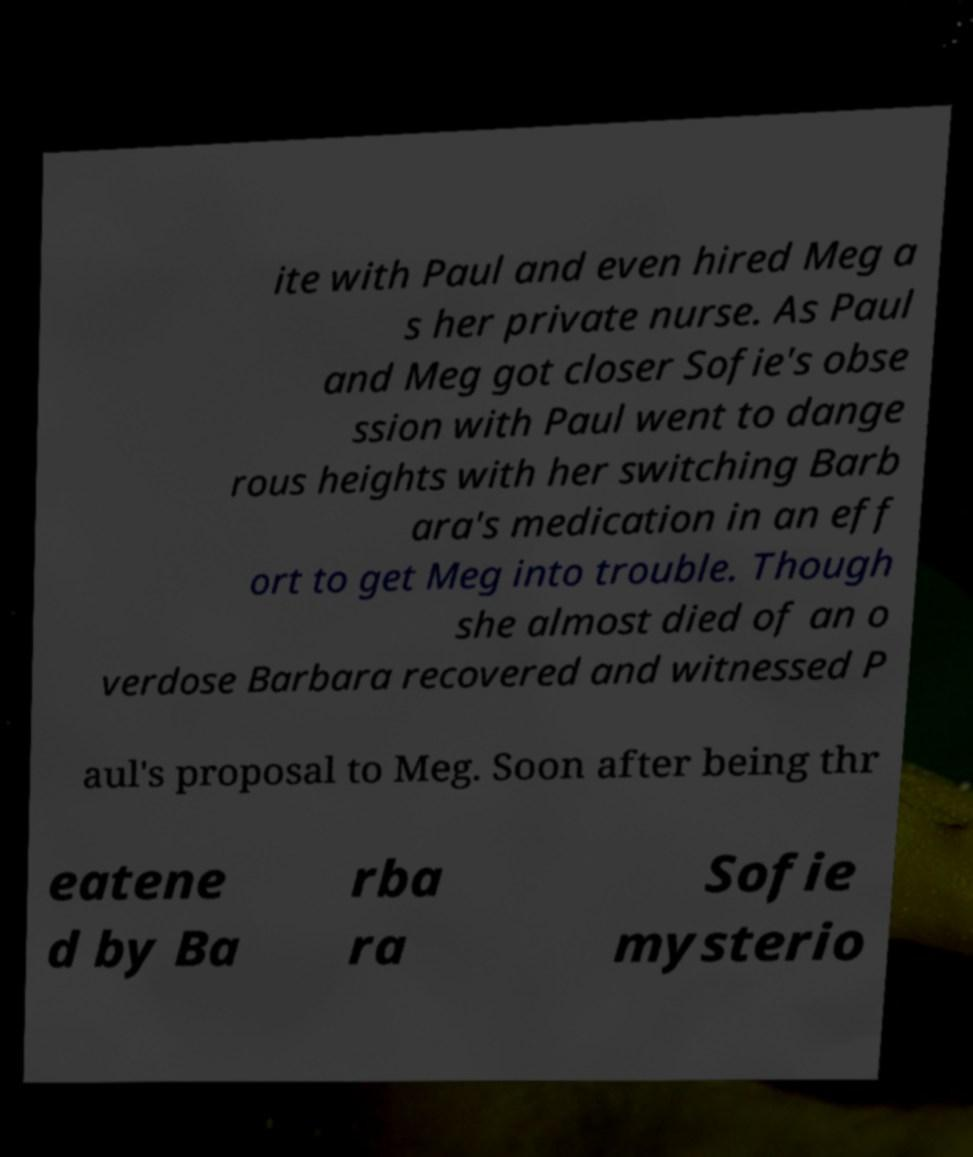There's text embedded in this image that I need extracted. Can you transcribe it verbatim? ite with Paul and even hired Meg a s her private nurse. As Paul and Meg got closer Sofie's obse ssion with Paul went to dange rous heights with her switching Barb ara's medication in an eff ort to get Meg into trouble. Though she almost died of an o verdose Barbara recovered and witnessed P aul's proposal to Meg. Soon after being thr eatene d by Ba rba ra Sofie mysterio 